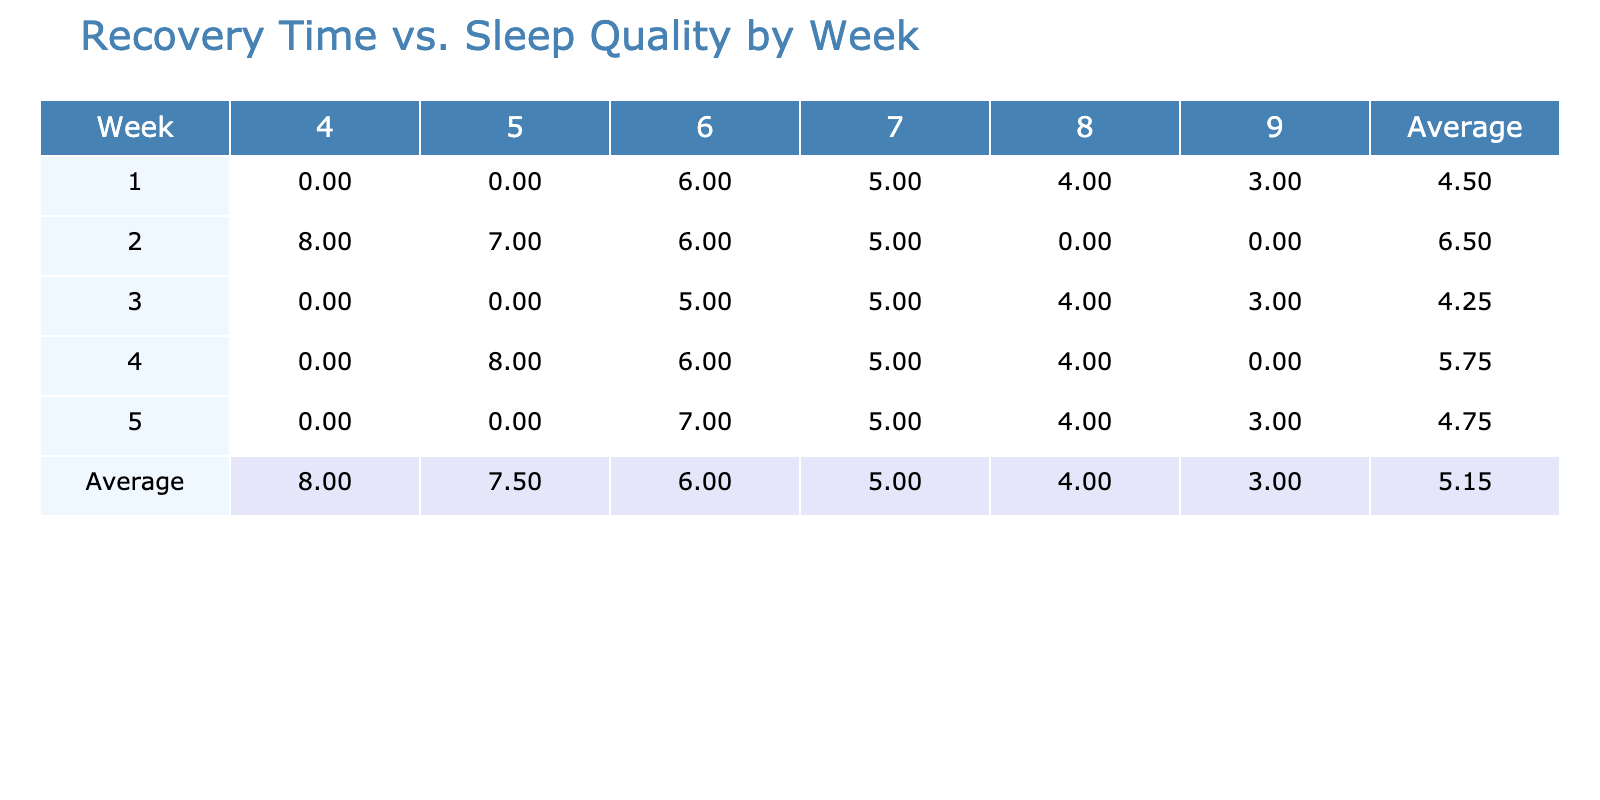What was the recovery time for Week 3 when the sleep quality was 9? In Week 3, when the sleep quality is 9, the recovery time listed is 3 hours.
Answer: 3 hours What is the average recovery time for Week 2? Summing the recovery times in Week 2 results in (7 + 8 + 5 + 6) = 26 hours. There are 4 data points, so the average recovery time is 26/4 = 6.5 hours.
Answer: 6.5 hours Was the recovery time for sleep quality 5 ever greater than 8 hours? Looking through the table, the maximum recovery time for sleep quality 5 is 8 hours in Week 2. Thus, the statement is true.
Answer: Yes What is the recovery time reduction from Week 1 to Week 2 when sleep quality is 6? In Week 1, the recovery time for sleep quality 6 is 6 hours, while in Week 2 it is 6 hours as well, so there is no reduction. 6 - 6 = 0 hours reduction.
Answer: 0 hours What was the trend of recovery time from Week 1 to Week 5 for sleep quality of 7? The recovery times for sleep quality 7 are as follows: Week 1 → 5 hours, Week 2 → 5 hours, Week 3 → 5 hours, Week 4 → 5 hours, and Week 5 → 5 hours. There is no change in recovery time, indicating stability (constant).
Answer: No change in recovery time What is the highest average recovery time across all weeks? The average recovery times across the weeks can be seen: Week 1 average = 5.5, Week 2 average = 6.5, Week 3 average = 5.25, Week 4 average = 5.5, and Week 5 average = 5.25. The highest is 6.5 from Week 2.
Answer: 6.5 hours Was there a consistent increase in sleep quality across all weeks? By reviewing the sleep quality values, Week 1 has values ranging from 6 to 9, Week 2 ranges from 4 to 7, Week 3 ranges from 6 to 9, Week 4 ranges from 5 to 8, and Week 5 ranges from 6 to 9. Since there are decreases present in Week 2 and Week 4, the increase is not consistent.
Answer: No What is the average recovery time for sleep quality 8 over all weeks? The recovery times for sleep quality 8 are: Week 1 → 4 hours, Week 2 → 8 hours, Week 3 → Not available, Week 4 → 6 hours, Week 5 → 4 hours. Thus, average = (4 + 8 + 6 + 4)/4 = 5.5 hours.
Answer: 5.5 hours 